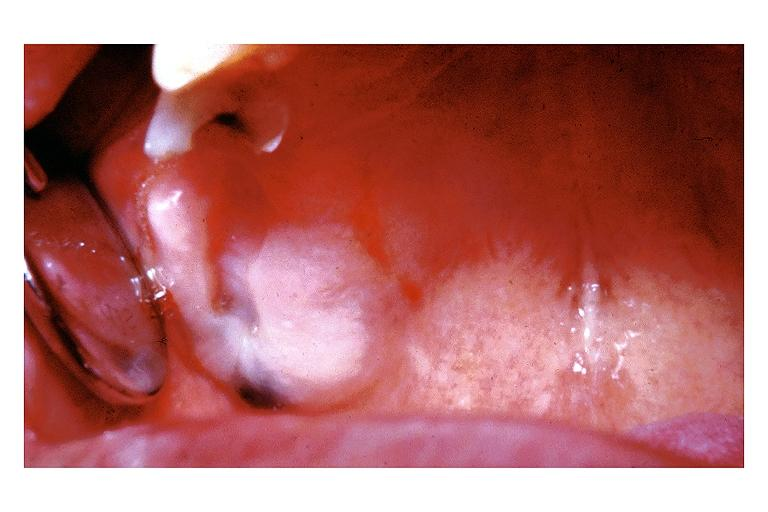does musculoskeletal show amalgam tattoo?
Answer the question using a single word or phrase. No 